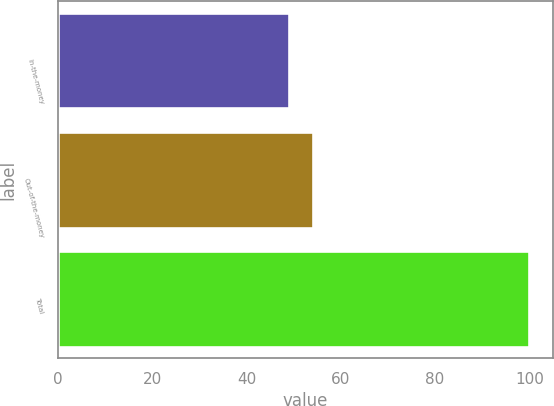Convert chart. <chart><loc_0><loc_0><loc_500><loc_500><bar_chart><fcel>In-the-money<fcel>Out-of-the-money<fcel>Total<nl><fcel>49<fcel>54.1<fcel>100<nl></chart> 